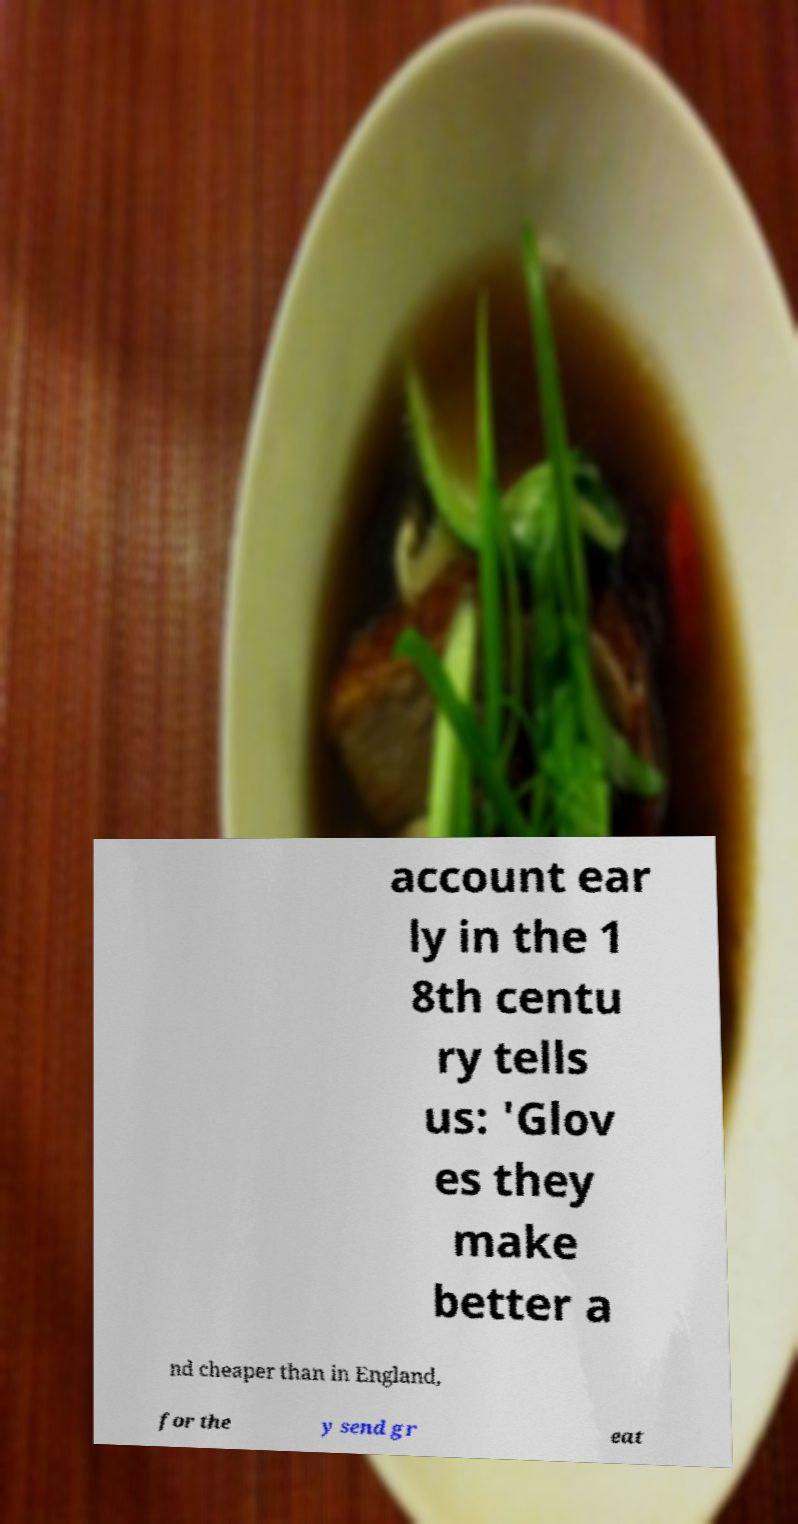What messages or text are displayed in this image? I need them in a readable, typed format. account ear ly in the 1 8th centu ry tells us: 'Glov es they make better a nd cheaper than in England, for the y send gr eat 